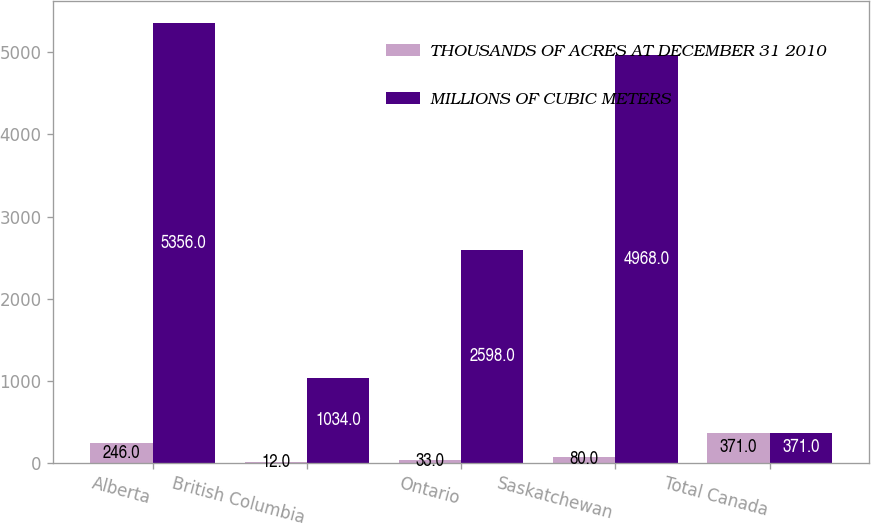Convert chart. <chart><loc_0><loc_0><loc_500><loc_500><stacked_bar_chart><ecel><fcel>Alberta<fcel>British Columbia<fcel>Ontario<fcel>Saskatchewan<fcel>Total Canada<nl><fcel>THOUSANDS OF ACRES AT DECEMBER 31 2010<fcel>246<fcel>12<fcel>33<fcel>80<fcel>371<nl><fcel>MILLIONS OF CUBIC METERS<fcel>5356<fcel>1034<fcel>2598<fcel>4968<fcel>371<nl></chart> 